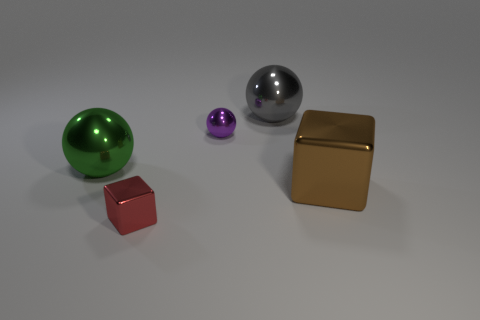Add 4 big matte cylinders. How many objects exist? 9 Subtract all big spheres. How many spheres are left? 1 Subtract all brown blocks. How many blocks are left? 1 Subtract all gray cylinders. How many red blocks are left? 1 Subtract 0 blue cylinders. How many objects are left? 5 Subtract all balls. How many objects are left? 2 Subtract 1 balls. How many balls are left? 2 Subtract all brown cubes. Subtract all yellow cylinders. How many cubes are left? 1 Subtract all big brown matte things. Subtract all purple metallic spheres. How many objects are left? 4 Add 5 large green metal spheres. How many large green metal spheres are left? 6 